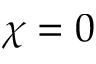Convert formula to latex. <formula><loc_0><loc_0><loc_500><loc_500>\chi = 0</formula> 